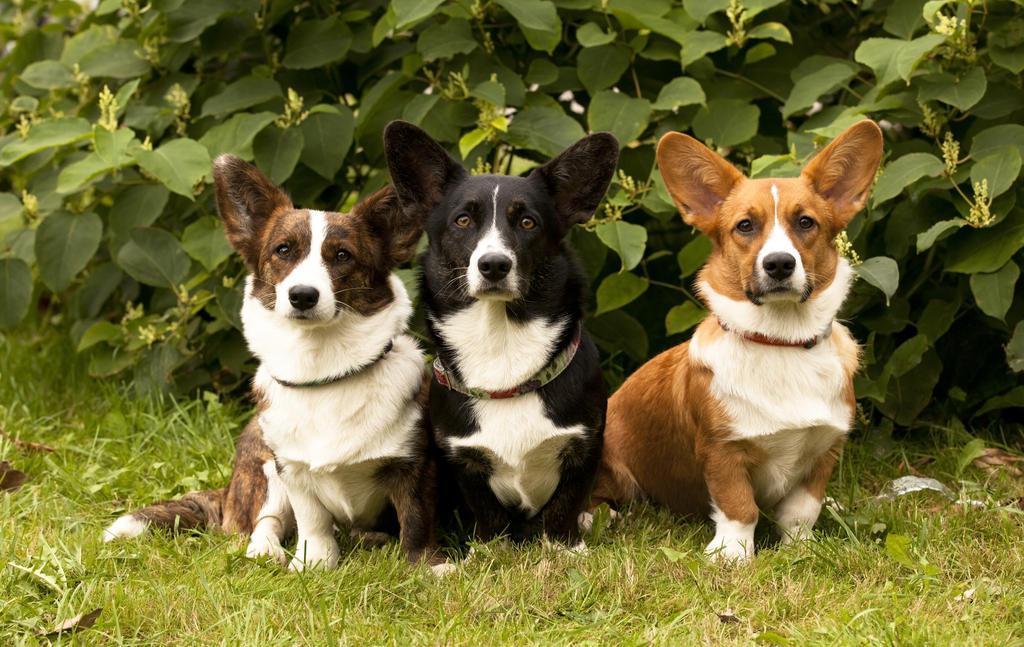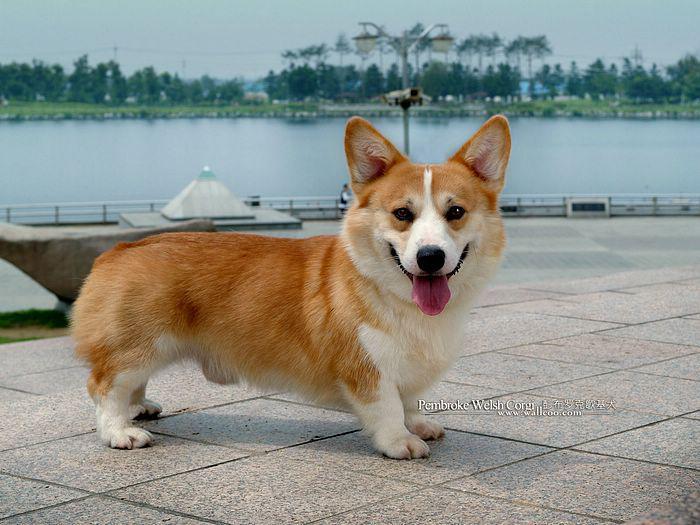The first image is the image on the left, the second image is the image on the right. Analyze the images presented: Is the assertion "In at least one image there are three dog sitting next to each other in the grass." valid? Answer yes or no. Yes. 